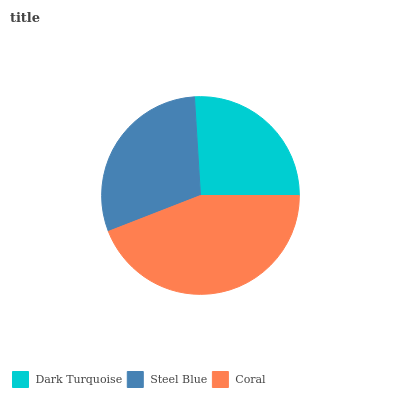Is Dark Turquoise the minimum?
Answer yes or no. Yes. Is Coral the maximum?
Answer yes or no. Yes. Is Steel Blue the minimum?
Answer yes or no. No. Is Steel Blue the maximum?
Answer yes or no. No. Is Steel Blue greater than Dark Turquoise?
Answer yes or no. Yes. Is Dark Turquoise less than Steel Blue?
Answer yes or no. Yes. Is Dark Turquoise greater than Steel Blue?
Answer yes or no. No. Is Steel Blue less than Dark Turquoise?
Answer yes or no. No. Is Steel Blue the high median?
Answer yes or no. Yes. Is Steel Blue the low median?
Answer yes or no. Yes. Is Coral the high median?
Answer yes or no. No. Is Coral the low median?
Answer yes or no. No. 